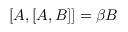<formula> <loc_0><loc_0><loc_500><loc_500>[ A , [ A , B ] ] = \beta B</formula> 